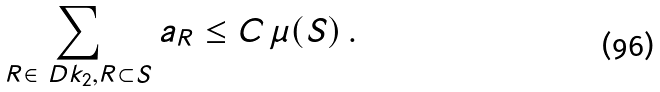Convert formula to latex. <formula><loc_0><loc_0><loc_500><loc_500>\sum _ { R \in \ D k _ { 2 } , R \subset S } a _ { R } \leq C \, \mu ( S ) \, .</formula> 